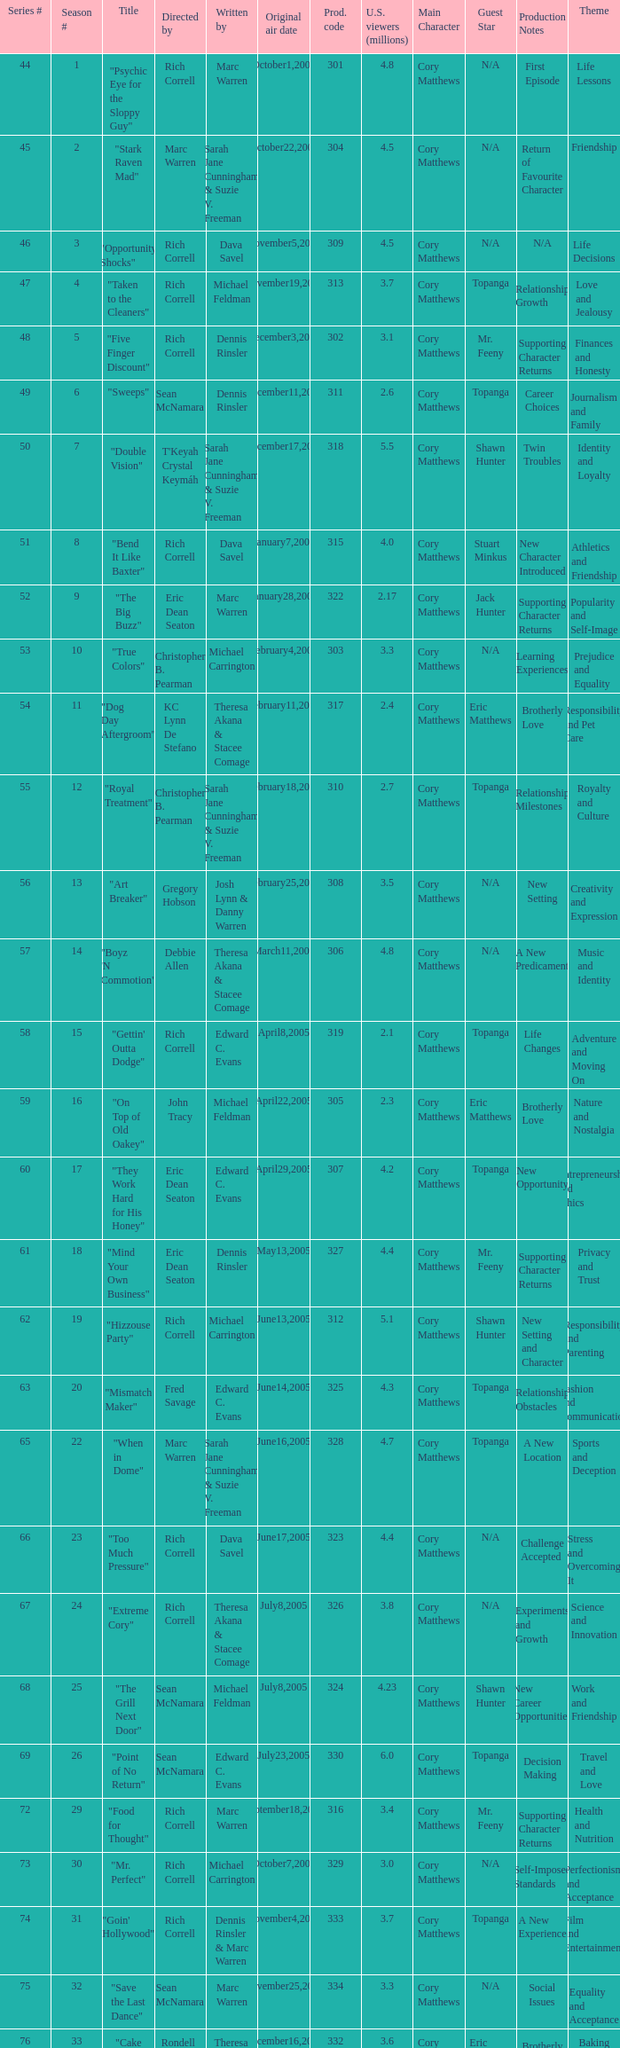What number episode in the season had a production code of 334? 32.0. Can you parse all the data within this table? {'header': ['Series #', 'Season #', 'Title', 'Directed by', 'Written by', 'Original air date', 'Prod. code', 'U.S. viewers (millions)', 'Main Character', 'Guest Star', 'Production Notes', 'Theme'], 'rows': [['44', '1', '"Psychic Eye for the Sloppy Guy"', 'Rich Correll', 'Marc Warren', 'October1,2004', '301', '4.8', 'Cory Matthews', 'N/A', 'First Episode', 'Life Lessons'], ['45', '2', '"Stark Raven Mad"', 'Marc Warren', 'Sarah Jane Cunningham & Suzie V. Freeman', 'October22,2004', '304', '4.5', 'Cory Matthews', 'N/A', 'Return of Favourite Character', 'Friendship'], ['46', '3', '"Opportunity Shocks"', 'Rich Correll', 'Dava Savel', 'November5,2004', '309', '4.5', 'Cory Matthews', 'N/A', 'N/A', 'Life Decisions'], ['47', '4', '"Taken to the Cleaners"', 'Rich Correll', 'Michael Feldman', 'November19,2004', '313', '3.7', 'Cory Matthews', 'Topanga', 'Relationship Growth', 'Love and Jealousy'], ['48', '5', '"Five Finger Discount"', 'Rich Correll', 'Dennis Rinsler', 'December3,2004', '302', '3.1', 'Cory Matthews', 'Mr. Feeny', 'Supporting Character Returns', 'Finances and Honesty'], ['49', '6', '"Sweeps"', 'Sean McNamara', 'Dennis Rinsler', 'December11,2004', '311', '2.6', 'Cory Matthews', 'Topanga', 'Career Choices', 'Journalism and Family'], ['50', '7', '"Double Vision"', "T'Keyah Crystal Keymáh", 'Sarah Jane Cunningham & Suzie V. Freeman', 'December17,2004', '318', '5.5', 'Cory Matthews', 'Shawn Hunter', 'Twin Troubles', 'Identity and Loyalty'], ['51', '8', '"Bend It Like Baxter"', 'Rich Correll', 'Dava Savel', 'January7,2005', '315', '4.0', 'Cory Matthews', 'Stuart Minkus', 'New Character Introduced', 'Athletics and Friendship'], ['52', '9', '"The Big Buzz"', 'Eric Dean Seaton', 'Marc Warren', 'January28,2005', '322', '2.17', 'Cory Matthews', 'Jack Hunter', 'Supporting Character Returns', 'Popularity and Self-Image'], ['53', '10', '"True Colors"', 'Christopher B. Pearman', 'Michael Carrington', 'February4,2005', '303', '3.3', 'Cory Matthews', 'N/A', 'Learning Experiences', 'Prejudice and Equality'], ['54', '11', '"Dog Day Aftergroom"', 'KC Lynn De Stefano', 'Theresa Akana & Stacee Comage', 'February11,2005', '317', '2.4', 'Cory Matthews', 'Eric Matthews', 'Brotherly Love', 'Responsibility and Pet Care'], ['55', '12', '"Royal Treatment"', 'Christopher B. Pearman', 'Sarah Jane Cunningham & Suzie V. Freeman', 'February18,2005', '310', '2.7', 'Cory Matthews', 'Topanga', 'Relationship Milestones', 'Royalty and Culture'], ['56', '13', '"Art Breaker"', 'Gregory Hobson', 'Josh Lynn & Danny Warren', 'February25,2005', '308', '3.5', 'Cory Matthews', 'N/A', 'New Setting', 'Creativity and Expression'], ['57', '14', '"Boyz \'N Commotion"', 'Debbie Allen', 'Theresa Akana & Stacee Comage', 'March11,2005', '306', '4.8', 'Cory Matthews', 'N/A', 'A New Predicament', 'Music and Identity'], ['58', '15', '"Gettin\' Outta Dodge"', 'Rich Correll', 'Edward C. Evans', 'April8,2005', '319', '2.1', 'Cory Matthews', 'Topanga', 'Life Changes', 'Adventure and Moving On'], ['59', '16', '"On Top of Old Oakey"', 'John Tracy', 'Michael Feldman', 'April22,2005', '305', '2.3', 'Cory Matthews', 'Eric Matthews', 'Brotherly Love', 'Nature and Nostalgia'], ['60', '17', '"They Work Hard for His Honey"', 'Eric Dean Seaton', 'Edward C. Evans', 'April29,2005', '307', '4.2', 'Cory Matthews', 'Topanga', 'New Opportunity', 'Entrepreneurship and Ethics'], ['61', '18', '"Mind Your Own Business"', 'Eric Dean Seaton', 'Dennis Rinsler', 'May13,2005', '327', '4.4', 'Cory Matthews', 'Mr. Feeny', 'Supporting Character Returns', 'Privacy and Trust'], ['62', '19', '"Hizzouse Party"', 'Rich Correll', 'Michael Carrington', 'June13,2005', '312', '5.1', 'Cory Matthews', 'Shawn Hunter', 'New Setting and Character', 'Responsibility and Parenting'], ['63', '20', '"Mismatch Maker"', 'Fred Savage', 'Edward C. Evans', 'June14,2005', '325', '4.3', 'Cory Matthews', 'Topanga', 'Relationship Obstacles', 'Fashion and Communication'], ['65', '22', '"When in Dome"', 'Marc Warren', 'Sarah Jane Cunningham & Suzie V. Freeman', 'June16,2005', '328', '4.7', 'Cory Matthews', 'Topanga', 'A New Location', 'Sports and Deception'], ['66', '23', '"Too Much Pressure"', 'Rich Correll', 'Dava Savel', 'June17,2005', '323', '4.4', 'Cory Matthews', 'N/A', 'Challenge Accepted', 'Stress and Overcoming It'], ['67', '24', '"Extreme Cory"', 'Rich Correll', 'Theresa Akana & Stacee Comage', 'July8,2005', '326', '3.8', 'Cory Matthews', 'N/A', 'Experiments and Growth', 'Science and Innovation'], ['68', '25', '"The Grill Next Door"', 'Sean McNamara', 'Michael Feldman', 'July8,2005', '324', '4.23', 'Cory Matthews', 'Shawn Hunter', 'New Career Opportunities', 'Work and Friendship'], ['69', '26', '"Point of No Return"', 'Sean McNamara', 'Edward C. Evans', 'July23,2005', '330', '6.0', 'Cory Matthews', 'Topanga', 'Decision Making', 'Travel and Love'], ['72', '29', '"Food for Thought"', 'Rich Correll', 'Marc Warren', 'September18,2005', '316', '3.4', 'Cory Matthews', 'Mr. Feeny', 'Supporting Character Returns', 'Health and Nutrition'], ['73', '30', '"Mr. Perfect"', 'Rich Correll', 'Michael Carrington', 'October7,2005', '329', '3.0', 'Cory Matthews', 'N/A', 'Self-Imposed Standards', 'Perfectionism and Acceptance'], ['74', '31', '"Goin\' Hollywood"', 'Rich Correll', 'Dennis Rinsler & Marc Warren', 'November4,2005', '333', '3.7', 'Cory Matthews', 'Topanga', 'A New Experience', 'Film and Entertainment'], ['75', '32', '"Save the Last Dance"', 'Sean McNamara', 'Marc Warren', 'November25,2005', '334', '3.3', 'Cory Matthews', 'N/A', 'Social Issues', 'Equality and Acceptance'], ['76', '33', '"Cake Fear"', 'Rondell Sheridan', 'Theresa Akana & Stacee Comage', 'December16,2005', '332', '3.6', 'Cory Matthews', 'Eric Matthews', 'Brotherly Love', 'Baking and Family'], ['77', '34', '"Vision Impossible"', 'Marc Warren', 'David Brookwell & Sean McNamara', 'January6,2006', '335', '4.7', 'Cory Matthews', 'Topanga', 'Problem-Solving', 'Magic and Perception']]} 